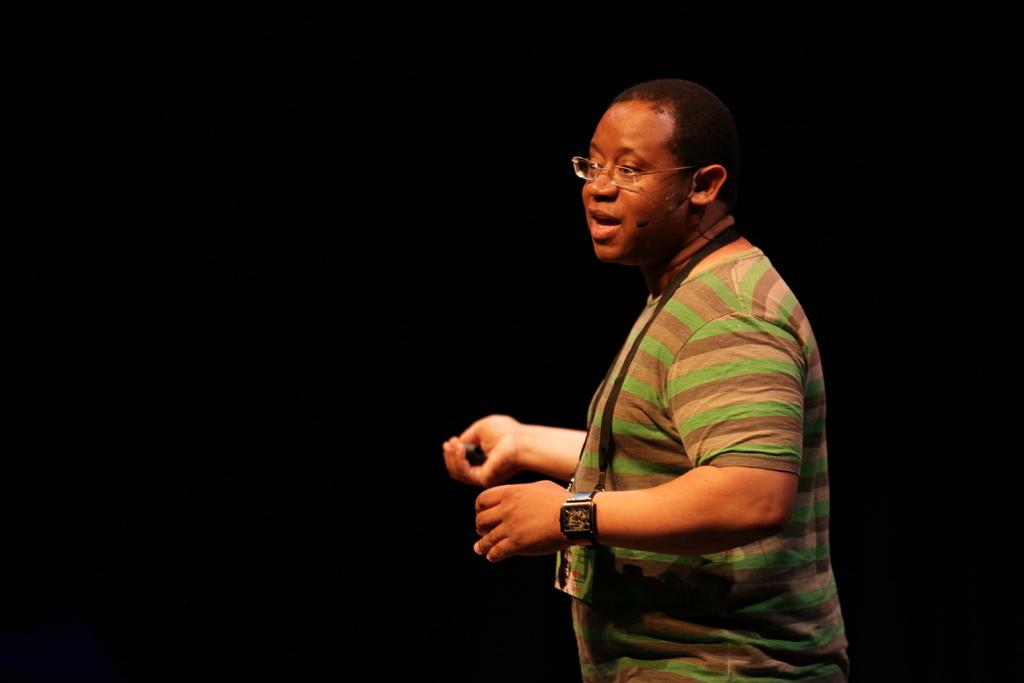Who is the main subject in the image? There is a person in the center of the image. What accessories is the person wearing? The person is wearing spectacles and a watch. What is the color of the background in the image? The background of the image is black in color. Can you hear the person laughing in the image? There is no sound in the image, so it is not possible to hear the person laughing. 